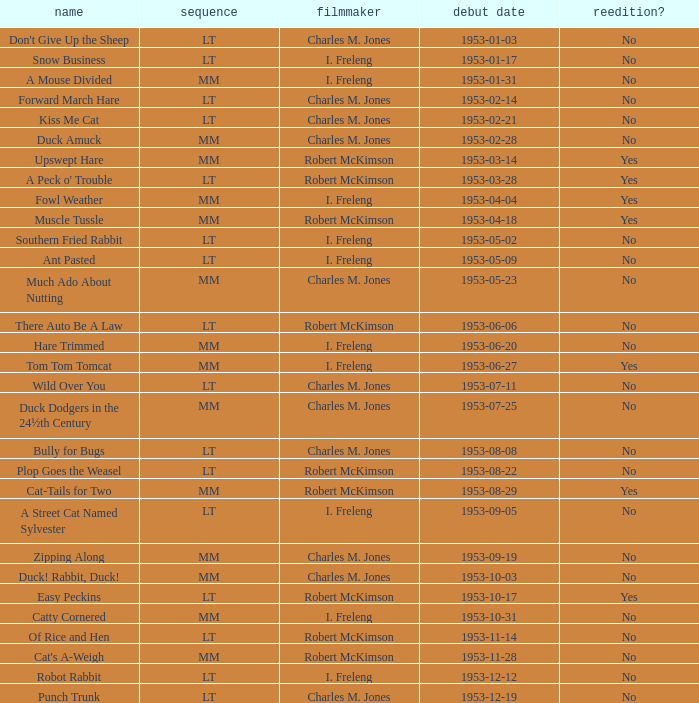What's the series of Kiss Me Cat? LT. 